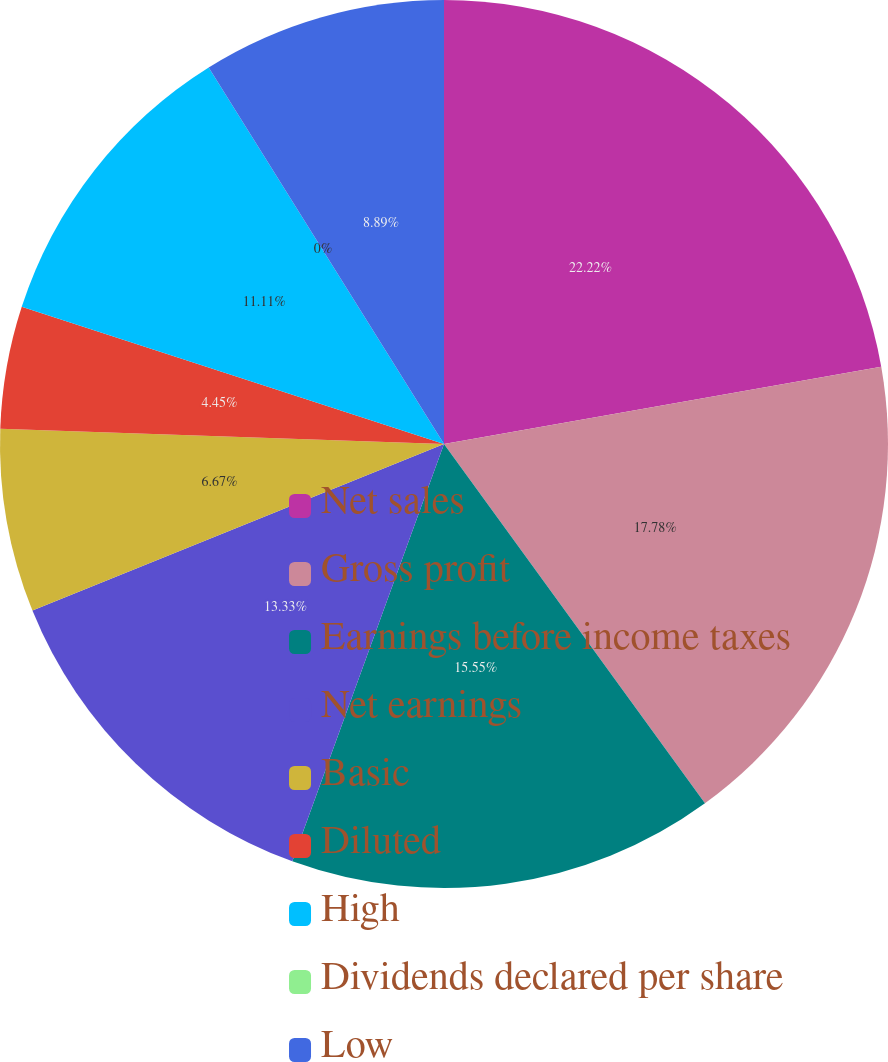<chart> <loc_0><loc_0><loc_500><loc_500><pie_chart><fcel>Net sales<fcel>Gross profit<fcel>Earnings before income taxes<fcel>Net earnings<fcel>Basic<fcel>Diluted<fcel>High<fcel>Dividends declared per share<fcel>Low<nl><fcel>22.22%<fcel>17.78%<fcel>15.55%<fcel>13.33%<fcel>6.67%<fcel>4.45%<fcel>11.11%<fcel>0.0%<fcel>8.89%<nl></chart> 